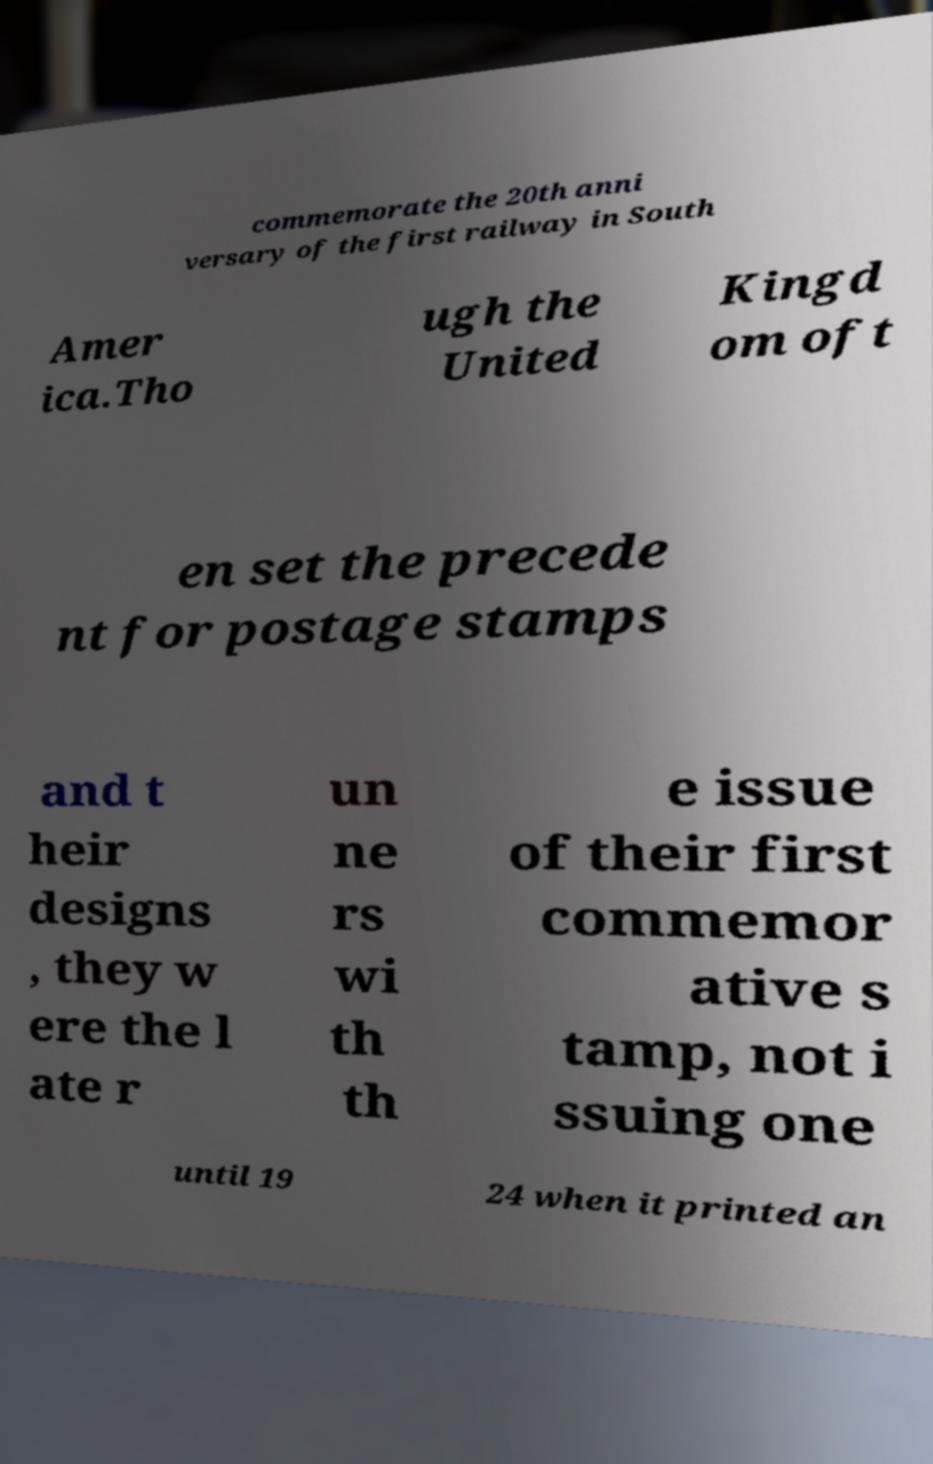Can you accurately transcribe the text from the provided image for me? commemorate the 20th anni versary of the first railway in South Amer ica.Tho ugh the United Kingd om oft en set the precede nt for postage stamps and t heir designs , they w ere the l ate r un ne rs wi th th e issue of their first commemor ative s tamp, not i ssuing one until 19 24 when it printed an 